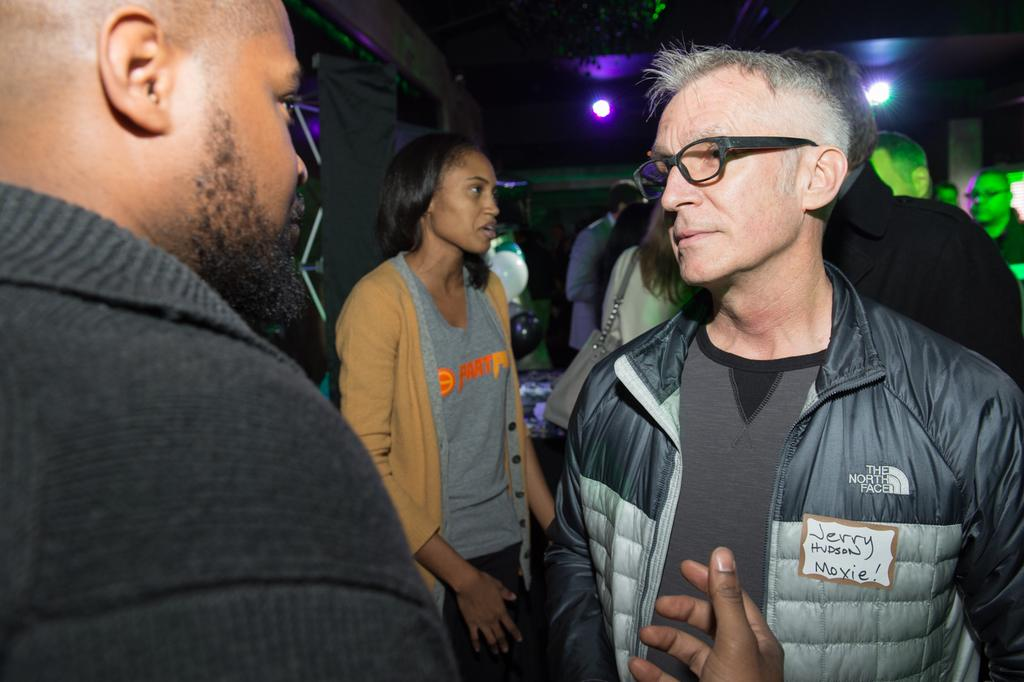What is present in the image? There are people standing in the image. What can be seen in the background of the image? There are lights and a wall in the background of the image. Where is the toad located in the image? There is no toad present in the image. What type of lock is used on the wall in the image? There is no lock present on the wall in the image. What type of oven can be seen in the image? There is no oven present in the image. 